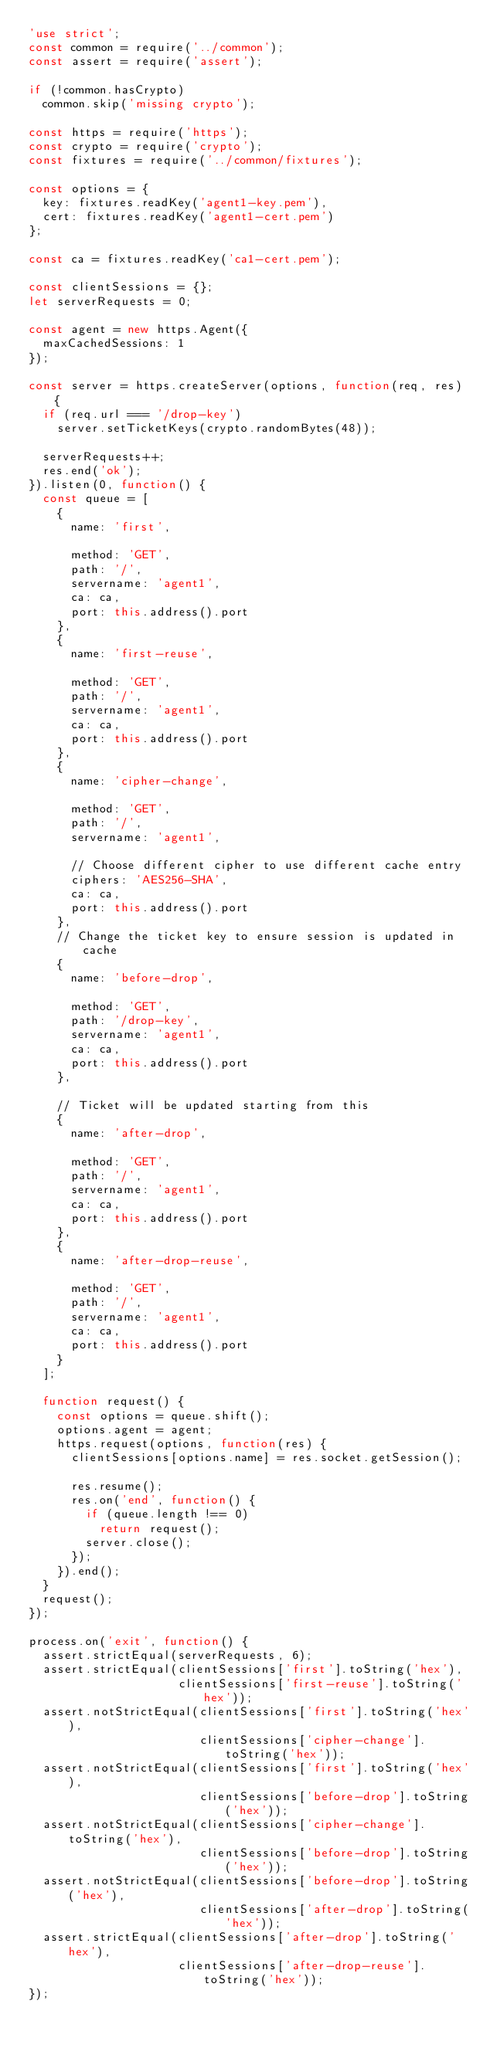Convert code to text. <code><loc_0><loc_0><loc_500><loc_500><_JavaScript_>'use strict';
const common = require('../common');
const assert = require('assert');

if (!common.hasCrypto)
  common.skip('missing crypto');

const https = require('https');
const crypto = require('crypto');
const fixtures = require('../common/fixtures');

const options = {
  key: fixtures.readKey('agent1-key.pem'),
  cert: fixtures.readKey('agent1-cert.pem')
};

const ca = fixtures.readKey('ca1-cert.pem');

const clientSessions = {};
let serverRequests = 0;

const agent = new https.Agent({
  maxCachedSessions: 1
});

const server = https.createServer(options, function(req, res) {
  if (req.url === '/drop-key')
    server.setTicketKeys(crypto.randomBytes(48));

  serverRequests++;
  res.end('ok');
}).listen(0, function() {
  const queue = [
    {
      name: 'first',

      method: 'GET',
      path: '/',
      servername: 'agent1',
      ca: ca,
      port: this.address().port
    },
    {
      name: 'first-reuse',

      method: 'GET',
      path: '/',
      servername: 'agent1',
      ca: ca,
      port: this.address().port
    },
    {
      name: 'cipher-change',

      method: 'GET',
      path: '/',
      servername: 'agent1',

      // Choose different cipher to use different cache entry
      ciphers: 'AES256-SHA',
      ca: ca,
      port: this.address().port
    },
    // Change the ticket key to ensure session is updated in cache
    {
      name: 'before-drop',

      method: 'GET',
      path: '/drop-key',
      servername: 'agent1',
      ca: ca,
      port: this.address().port
    },

    // Ticket will be updated starting from this
    {
      name: 'after-drop',

      method: 'GET',
      path: '/',
      servername: 'agent1',
      ca: ca,
      port: this.address().port
    },
    {
      name: 'after-drop-reuse',

      method: 'GET',
      path: '/',
      servername: 'agent1',
      ca: ca,
      port: this.address().port
    }
  ];

  function request() {
    const options = queue.shift();
    options.agent = agent;
    https.request(options, function(res) {
      clientSessions[options.name] = res.socket.getSession();

      res.resume();
      res.on('end', function() {
        if (queue.length !== 0)
          return request();
        server.close();
      });
    }).end();
  }
  request();
});

process.on('exit', function() {
  assert.strictEqual(serverRequests, 6);
  assert.strictEqual(clientSessions['first'].toString('hex'),
                     clientSessions['first-reuse'].toString('hex'));
  assert.notStrictEqual(clientSessions['first'].toString('hex'),
                        clientSessions['cipher-change'].toString('hex'));
  assert.notStrictEqual(clientSessions['first'].toString('hex'),
                        clientSessions['before-drop'].toString('hex'));
  assert.notStrictEqual(clientSessions['cipher-change'].toString('hex'),
                        clientSessions['before-drop'].toString('hex'));
  assert.notStrictEqual(clientSessions['before-drop'].toString('hex'),
                        clientSessions['after-drop'].toString('hex'));
  assert.strictEqual(clientSessions['after-drop'].toString('hex'),
                     clientSessions['after-drop-reuse'].toString('hex'));
});
</code> 